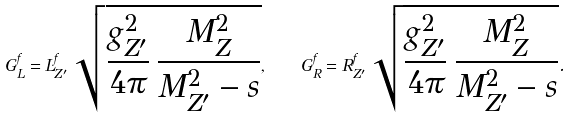<formula> <loc_0><loc_0><loc_500><loc_500>G ^ { f } _ { L } = L ^ { f } _ { Z ^ { \prime } } \, \sqrt { \frac { g ^ { 2 } _ { Z ^ { \prime } } } { 4 \pi } \, \frac { M ^ { 2 } _ { Z } } { M ^ { 2 } _ { Z ^ { \prime } } - s } } , \quad G ^ { f } _ { R } = R ^ { f } _ { Z ^ { \prime } } \, \sqrt { \frac { g ^ { 2 } _ { Z ^ { \prime } } } { 4 \pi } \, \frac { M ^ { 2 } _ { Z } } { M ^ { 2 } _ { Z ^ { \prime } } - s } } .</formula> 